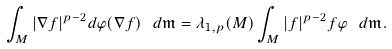Convert formula to latex. <formula><loc_0><loc_0><loc_500><loc_500>\int _ { M } | \nabla f | ^ { p - 2 } d \varphi ( \nabla f ) \ d \mathfrak { m } = \lambda _ { 1 , p } ( M ) \int _ { M } | f | ^ { p - 2 } f \varphi \ d \mathfrak { m } .</formula> 